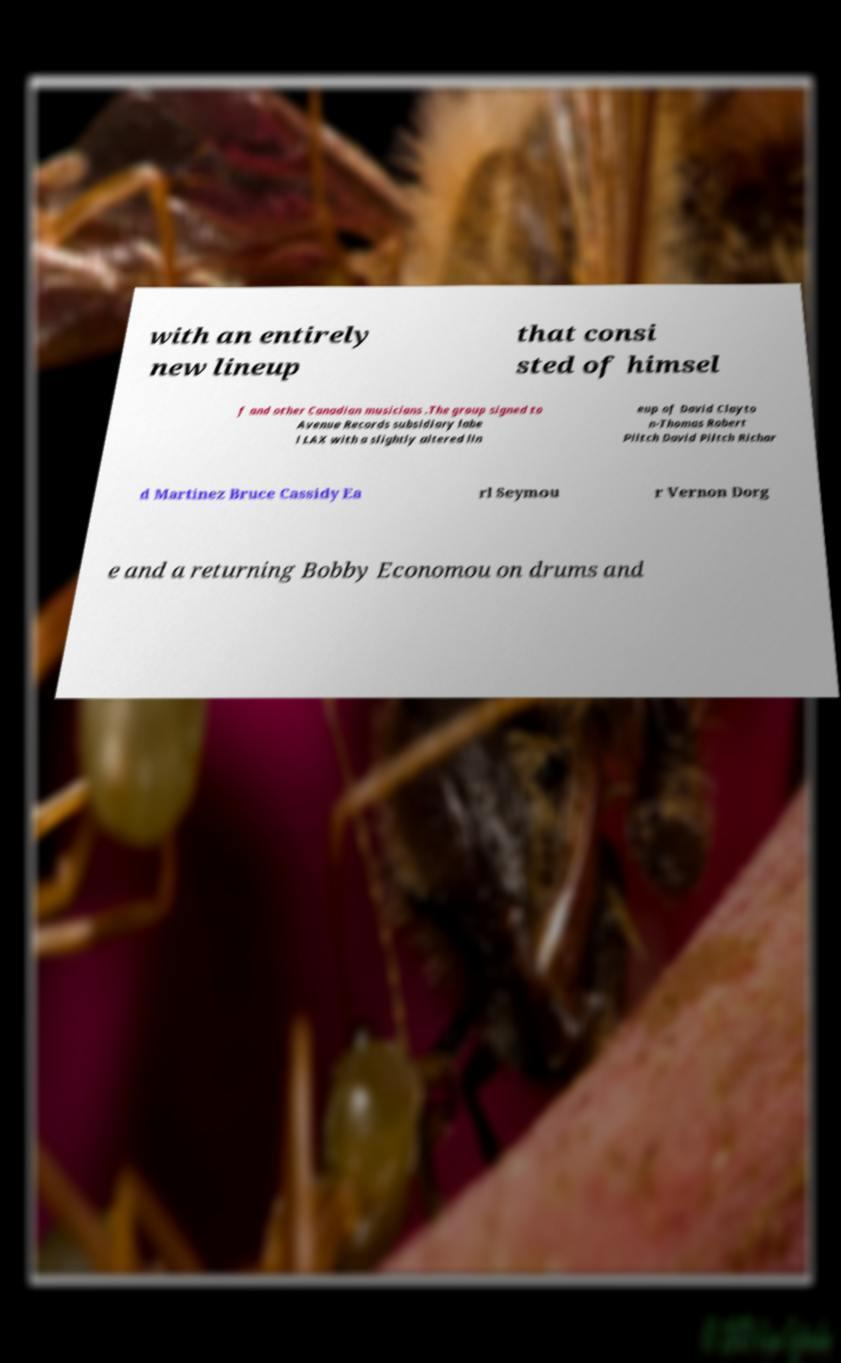What messages or text are displayed in this image? I need them in a readable, typed format. with an entirely new lineup that consi sted of himsel f and other Canadian musicians .The group signed to Avenue Records subsidiary labe l LAX with a slightly altered lin eup of David Clayto n-Thomas Robert Piltch David Piltch Richar d Martinez Bruce Cassidy Ea rl Seymou r Vernon Dorg e and a returning Bobby Economou on drums and 